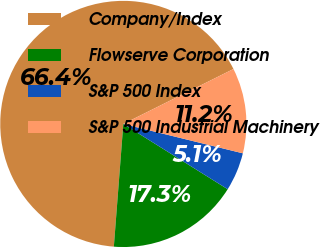Convert chart. <chart><loc_0><loc_0><loc_500><loc_500><pie_chart><fcel>Company/Index<fcel>Flowserve Corporation<fcel>S&P 500 Index<fcel>S&P 500 Industrial Machinery<nl><fcel>66.4%<fcel>17.33%<fcel>5.06%<fcel>11.2%<nl></chart> 